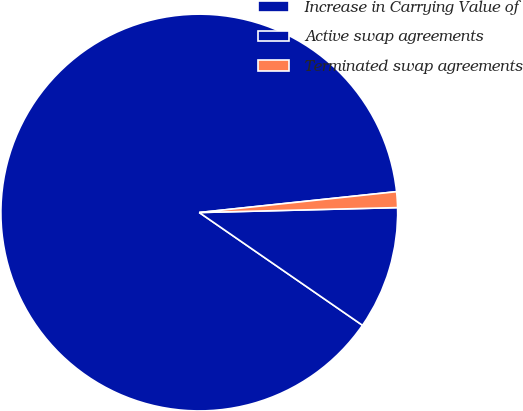Convert chart to OTSL. <chart><loc_0><loc_0><loc_500><loc_500><pie_chart><fcel>Increase in Carrying Value of<fcel>Active swap agreements<fcel>Terminated swap agreements<nl><fcel>88.7%<fcel>10.02%<fcel>1.28%<nl></chart> 